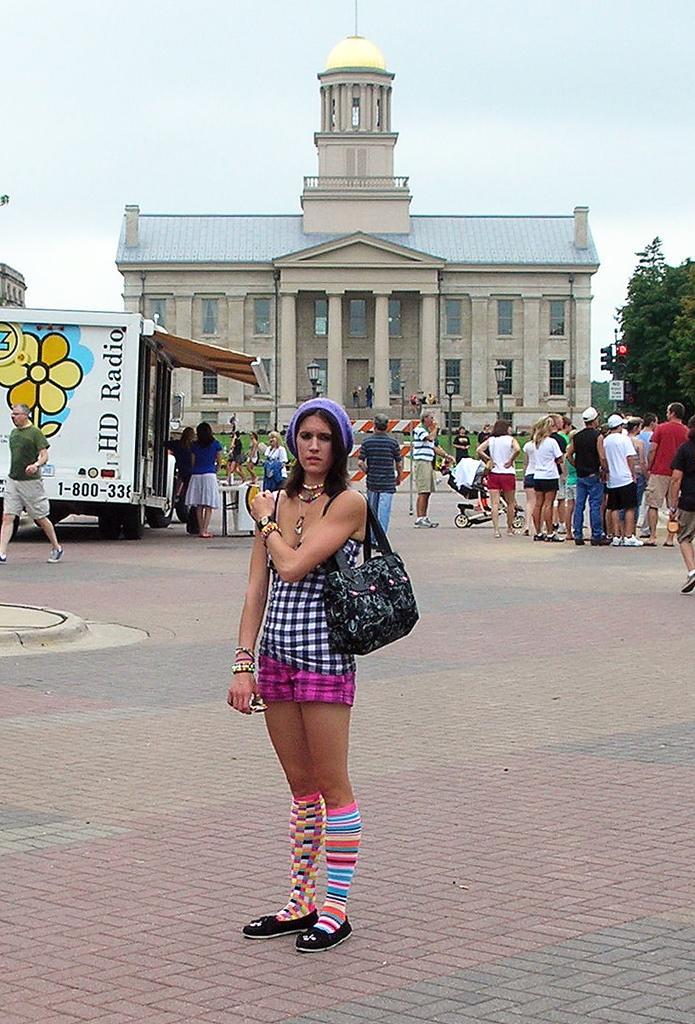Please provide a concise description of this image. In the picture we can see a woman standing on the path wearing a handbag and she is wearing a different colors of socks and in the background, we can see a building with some pillars to it and some construction on it with some pillars and beside to it we can see a tree and a sky and some people standing near the building and we can also see some vehicle. 